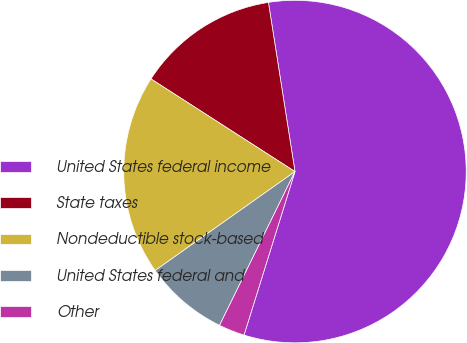<chart> <loc_0><loc_0><loc_500><loc_500><pie_chart><fcel>United States federal income<fcel>State taxes<fcel>Nondeductible stock-based<fcel>United States federal and<fcel>Other<nl><fcel>57.28%<fcel>13.42%<fcel>18.9%<fcel>7.94%<fcel>2.45%<nl></chart> 